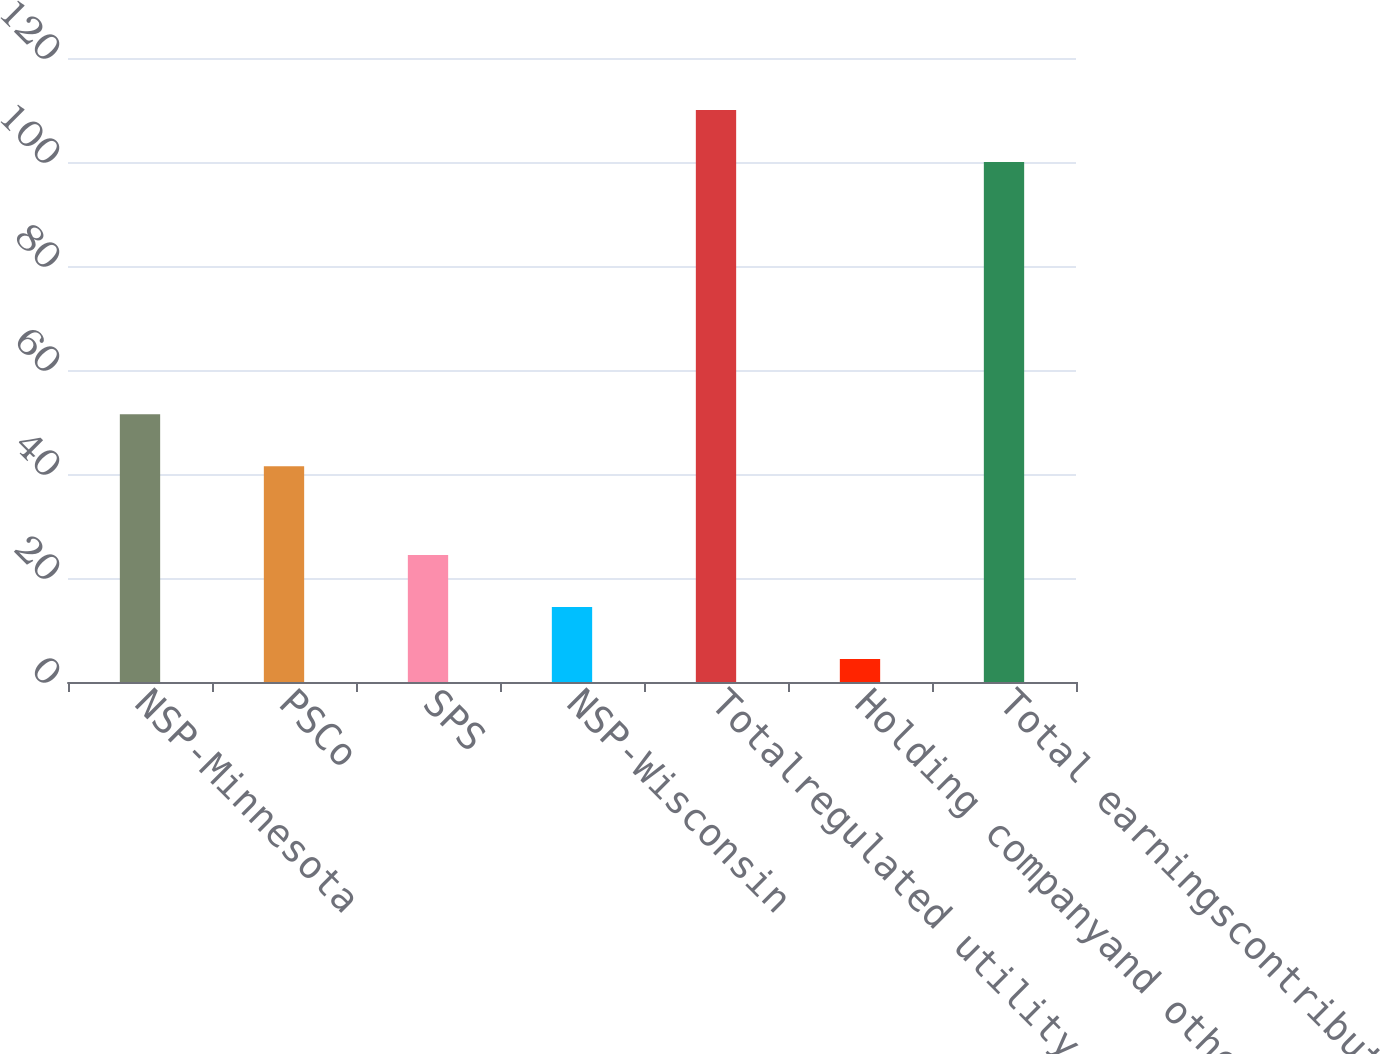<chart> <loc_0><loc_0><loc_500><loc_500><bar_chart><fcel>NSP-Minnesota<fcel>PSCo<fcel>SPS<fcel>NSP-Wisconsin<fcel>Totalregulated utility<fcel>Holding companyand other<fcel>Total earningscontributions<nl><fcel>51.5<fcel>41.5<fcel>24.4<fcel>14.4<fcel>110<fcel>4.4<fcel>100<nl></chart> 